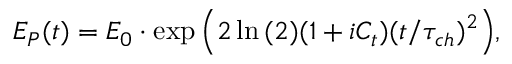<formula> <loc_0><loc_0><loc_500><loc_500>E _ { P } ( t ) = E _ { 0 } \cdot \exp { \left ( 2 \ln { ( 2 ) } ( 1 + i C _ { t } ) ( t / \tau _ { c h } ) ^ { 2 } \right ) } ,</formula> 